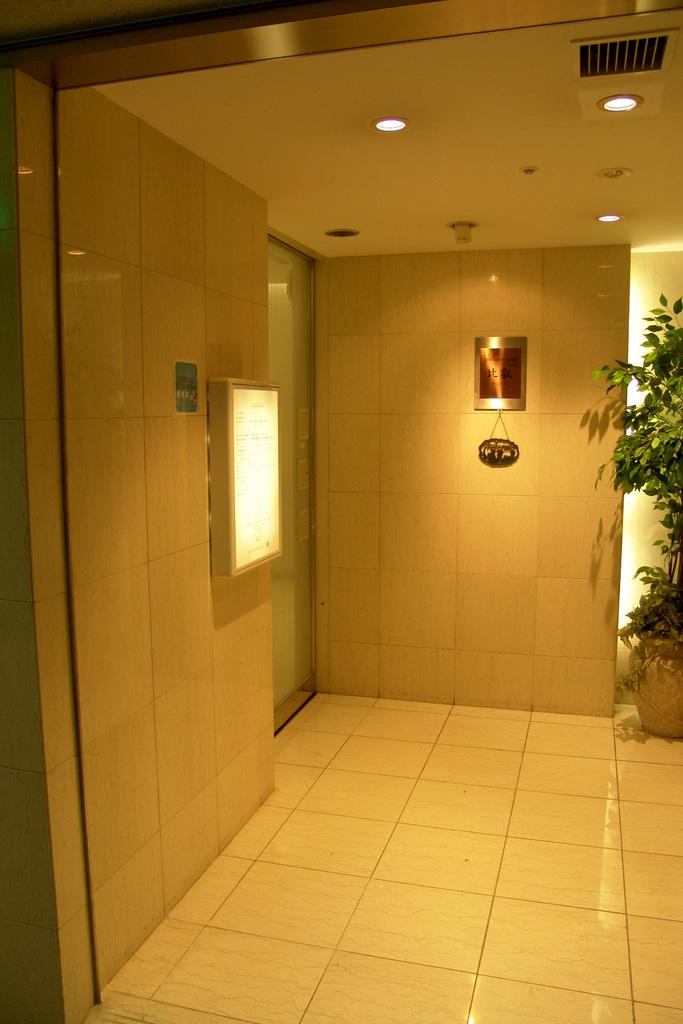What type of structure is visible in the image? There are walls visible in the image, which suggests a house or building. What type of vegetation is present in the image? There is a house plant in the image. What type of lighting is installed on the roof in the image? There are electric lights attached to the roof in the image. What type of stem can be seen growing from the walls in the image? There is no stem growing from the walls in the image. What type of pipe is visible running along the roof in the image? There is no pipe visible running along the roof in the image. What type of insect can be seen crawling on the house plant in the image? There is no insect, such as a beetle, visible crawling on the house plant in the image. 